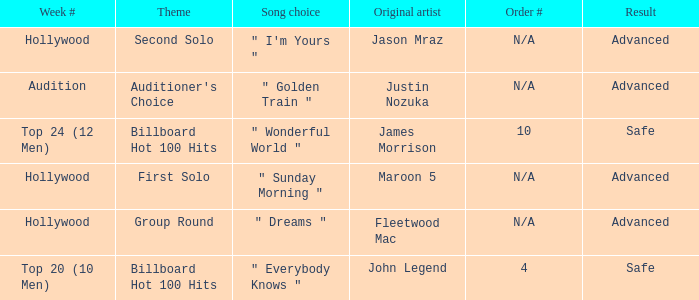What are all of the order # where authentic artist is maroon 5 N/A. 